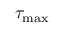<formula> <loc_0><loc_0><loc_500><loc_500>\tau _ { \max }</formula> 